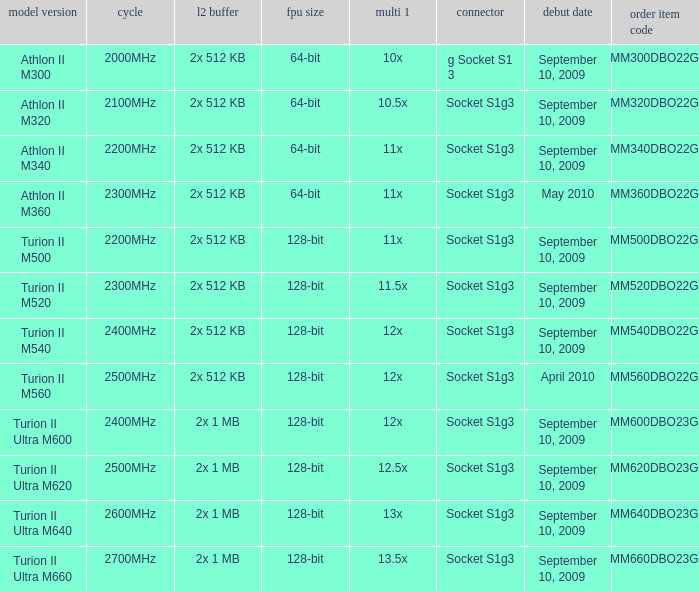What is the socket with an order part number of amm300dbo22gq and a September 10, 2009 release date? G socket s1 3. 